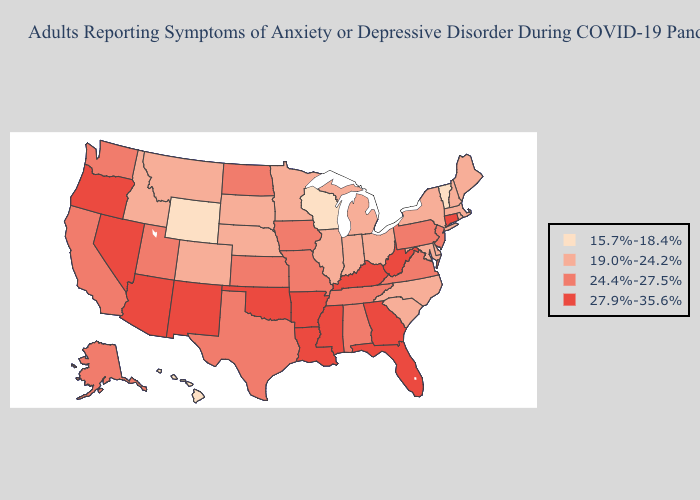Does Montana have the highest value in the USA?
Short answer required. No. Among the states that border Kansas , does Oklahoma have the highest value?
Keep it brief. Yes. Does South Dakota have the highest value in the USA?
Answer briefly. No. Does Oklahoma have the same value as Florida?
Quick response, please. Yes. Name the states that have a value in the range 24.4%-27.5%?
Write a very short answer. Alabama, Alaska, California, Iowa, Kansas, Missouri, New Jersey, North Dakota, Pennsylvania, Tennessee, Texas, Utah, Virginia, Washington. Name the states that have a value in the range 27.9%-35.6%?
Keep it brief. Arizona, Arkansas, Connecticut, Florida, Georgia, Kentucky, Louisiana, Mississippi, Nevada, New Mexico, Oklahoma, Oregon, West Virginia. Name the states that have a value in the range 24.4%-27.5%?
Quick response, please. Alabama, Alaska, California, Iowa, Kansas, Missouri, New Jersey, North Dakota, Pennsylvania, Tennessee, Texas, Utah, Virginia, Washington. What is the value of Alabama?
Be succinct. 24.4%-27.5%. Which states have the lowest value in the USA?
Keep it brief. Hawaii, Vermont, Wisconsin, Wyoming. What is the lowest value in the MidWest?
Keep it brief. 15.7%-18.4%. Which states have the lowest value in the USA?
Keep it brief. Hawaii, Vermont, Wisconsin, Wyoming. What is the value of Connecticut?
Give a very brief answer. 27.9%-35.6%. Among the states that border Kentucky , does West Virginia have the highest value?
Short answer required. Yes. What is the lowest value in the Northeast?
Keep it brief. 15.7%-18.4%. Among the states that border Virginia , does North Carolina have the highest value?
Give a very brief answer. No. 